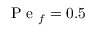<formula> <loc_0><loc_0><loc_500><loc_500>P e _ { f } = 0 . 5</formula> 